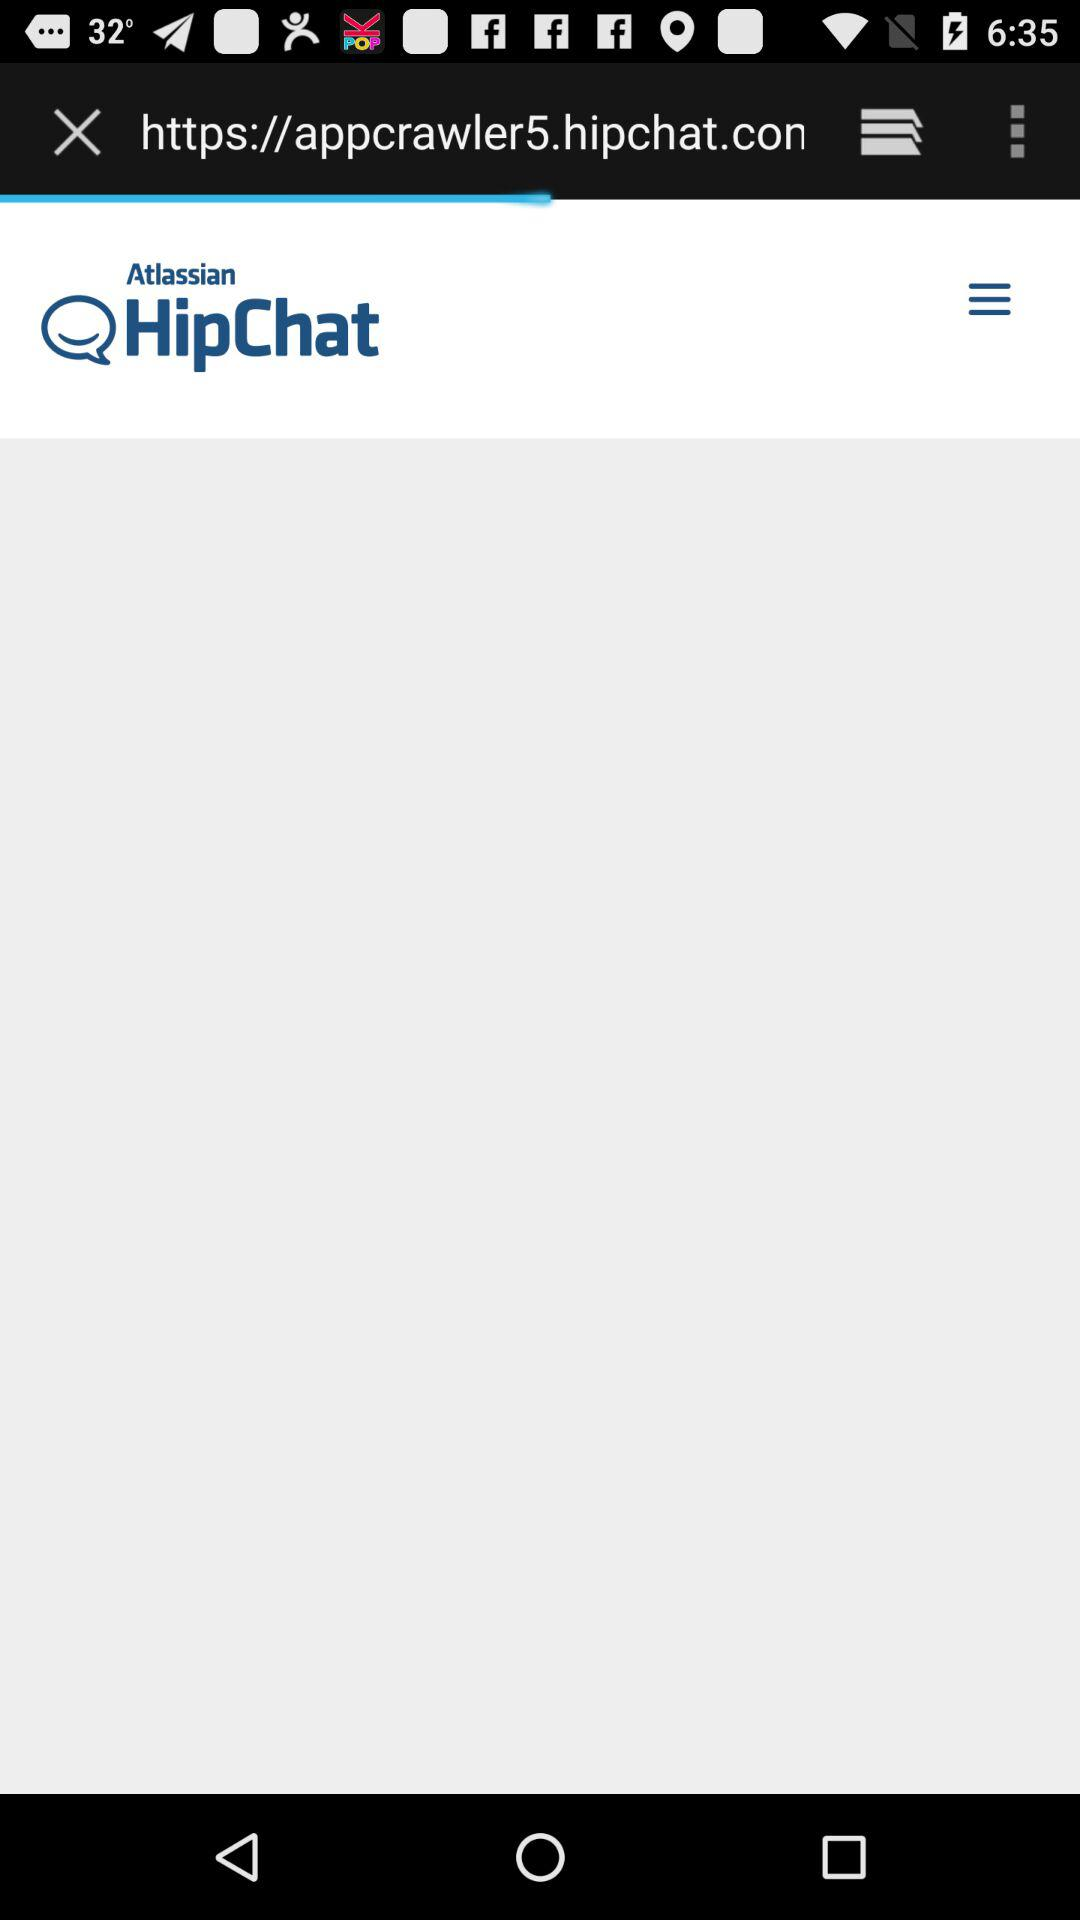What is the application name? The application name is "HipChat". 